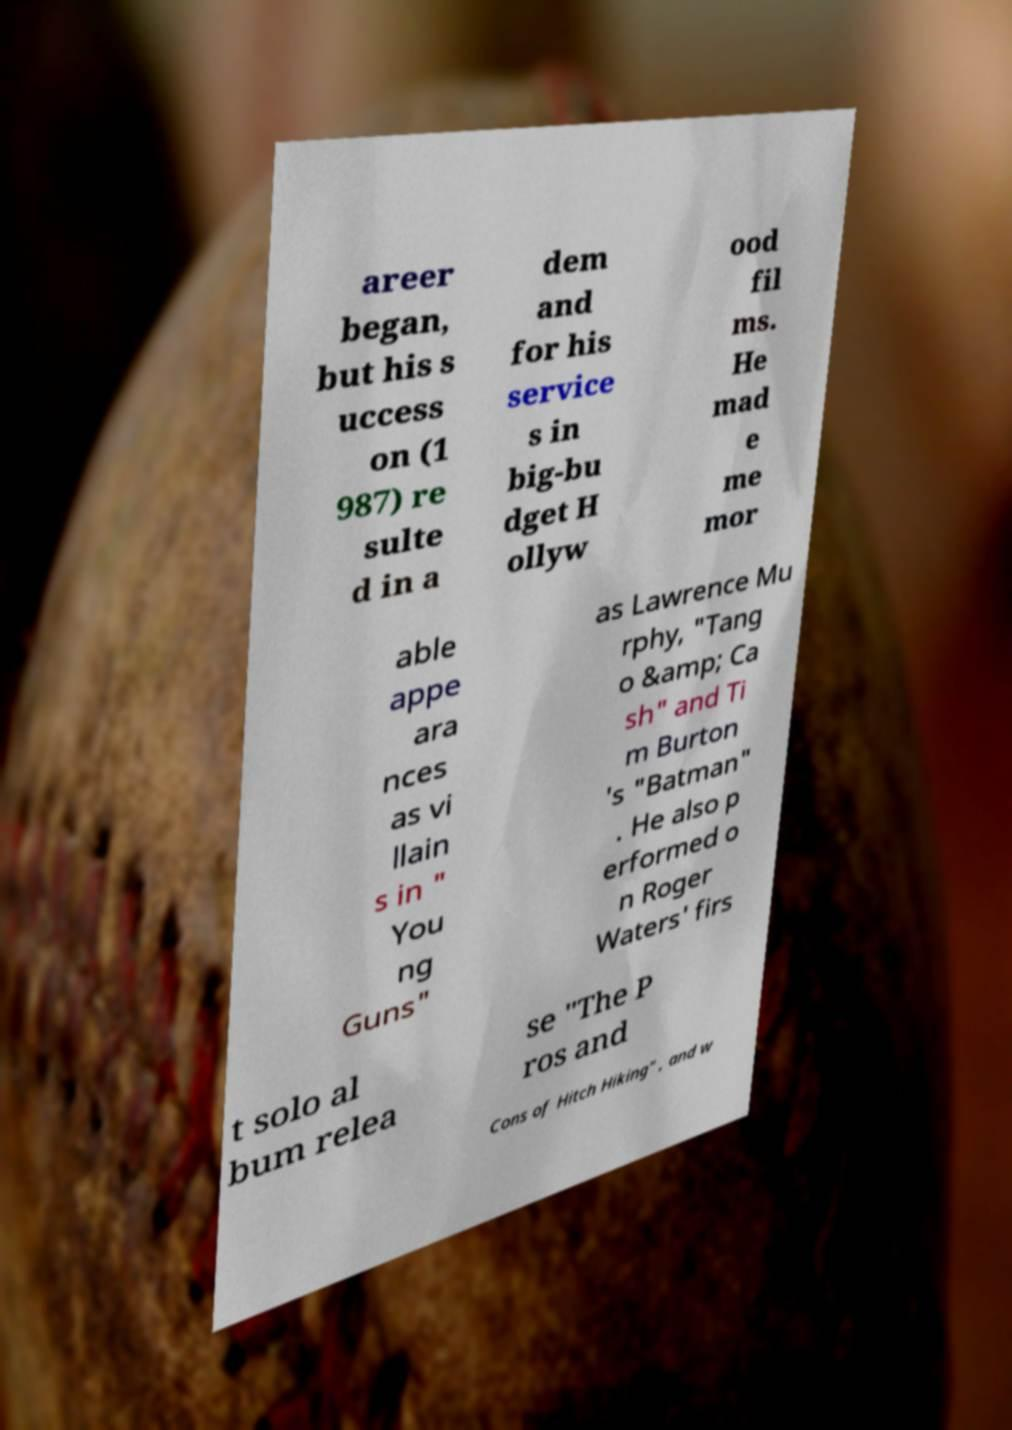For documentation purposes, I need the text within this image transcribed. Could you provide that? areer began, but his s uccess on (1 987) re sulte d in a dem and for his service s in big-bu dget H ollyw ood fil ms. He mad e me mor able appe ara nces as vi llain s in " You ng Guns" as Lawrence Mu rphy, "Tang o &amp; Ca sh" and Ti m Burton 's "Batman" . He also p erformed o n Roger Waters' firs t solo al bum relea se "The P ros and Cons of Hitch Hiking" , and w 